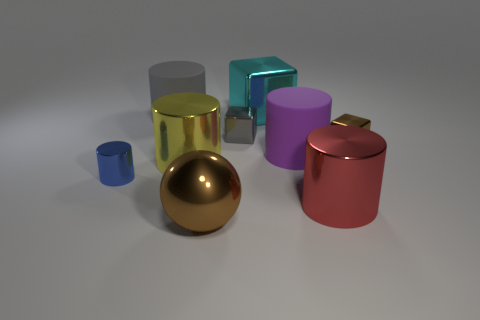Are there an equal number of small blue metallic things right of the big ball and big metal objects in front of the big cyan cube?
Your answer should be compact. No. What number of other objects are the same color as the small metal cylinder?
Your answer should be very brief. 0. Does the large metal cube have the same color as the tiny shiny thing on the right side of the tiny gray metal object?
Make the answer very short. No. How many green objects are either big metal cylinders or matte cylinders?
Your answer should be compact. 0. Is the number of shiny cylinders that are to the left of the big cyan shiny thing the same as the number of metal blocks?
Offer a terse response. No. Is there any other thing that has the same size as the cyan cube?
Offer a very short reply. Yes. The other big matte object that is the same shape as the purple object is what color?
Your answer should be very brief. Gray. How many small brown metal objects are the same shape as the big red metallic thing?
Offer a very short reply. 0. What is the material of the cube that is the same color as the large ball?
Offer a terse response. Metal. What number of large purple matte objects are there?
Provide a short and direct response. 1. 